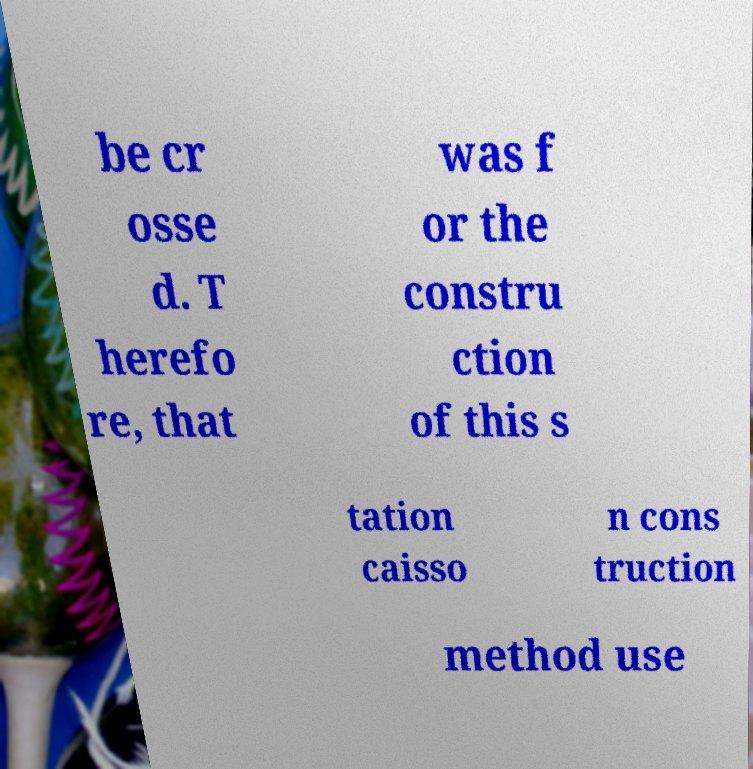I need the written content from this picture converted into text. Can you do that? be cr osse d. T herefo re, that was f or the constru ction of this s tation caisso n cons truction method use 